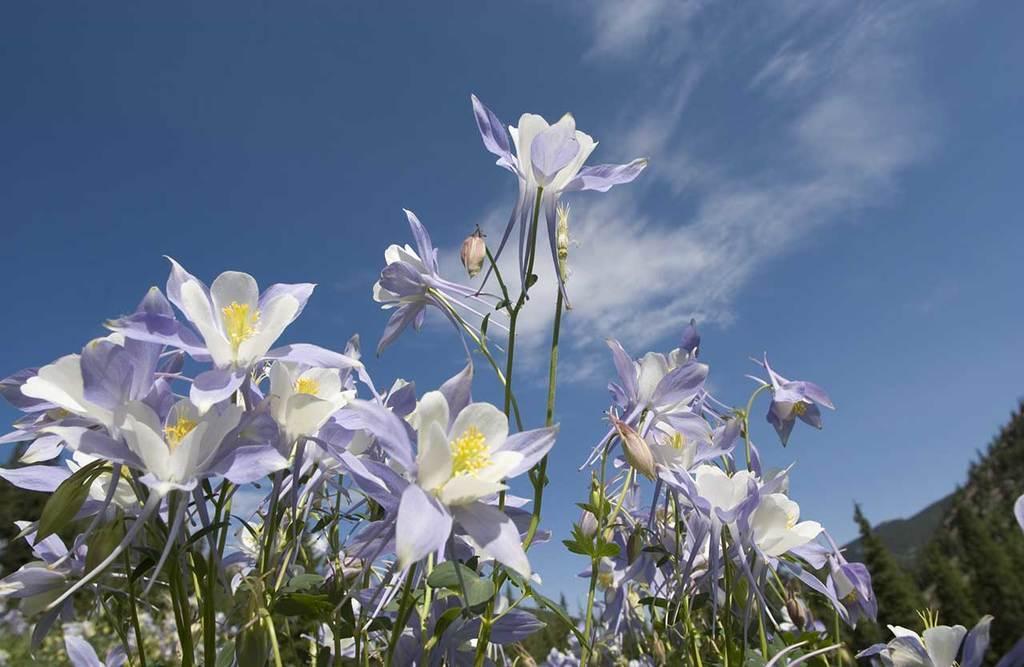Describe this image in one or two sentences. In this image we can see flowers and plants. In the background of the image there are trees, sky. 